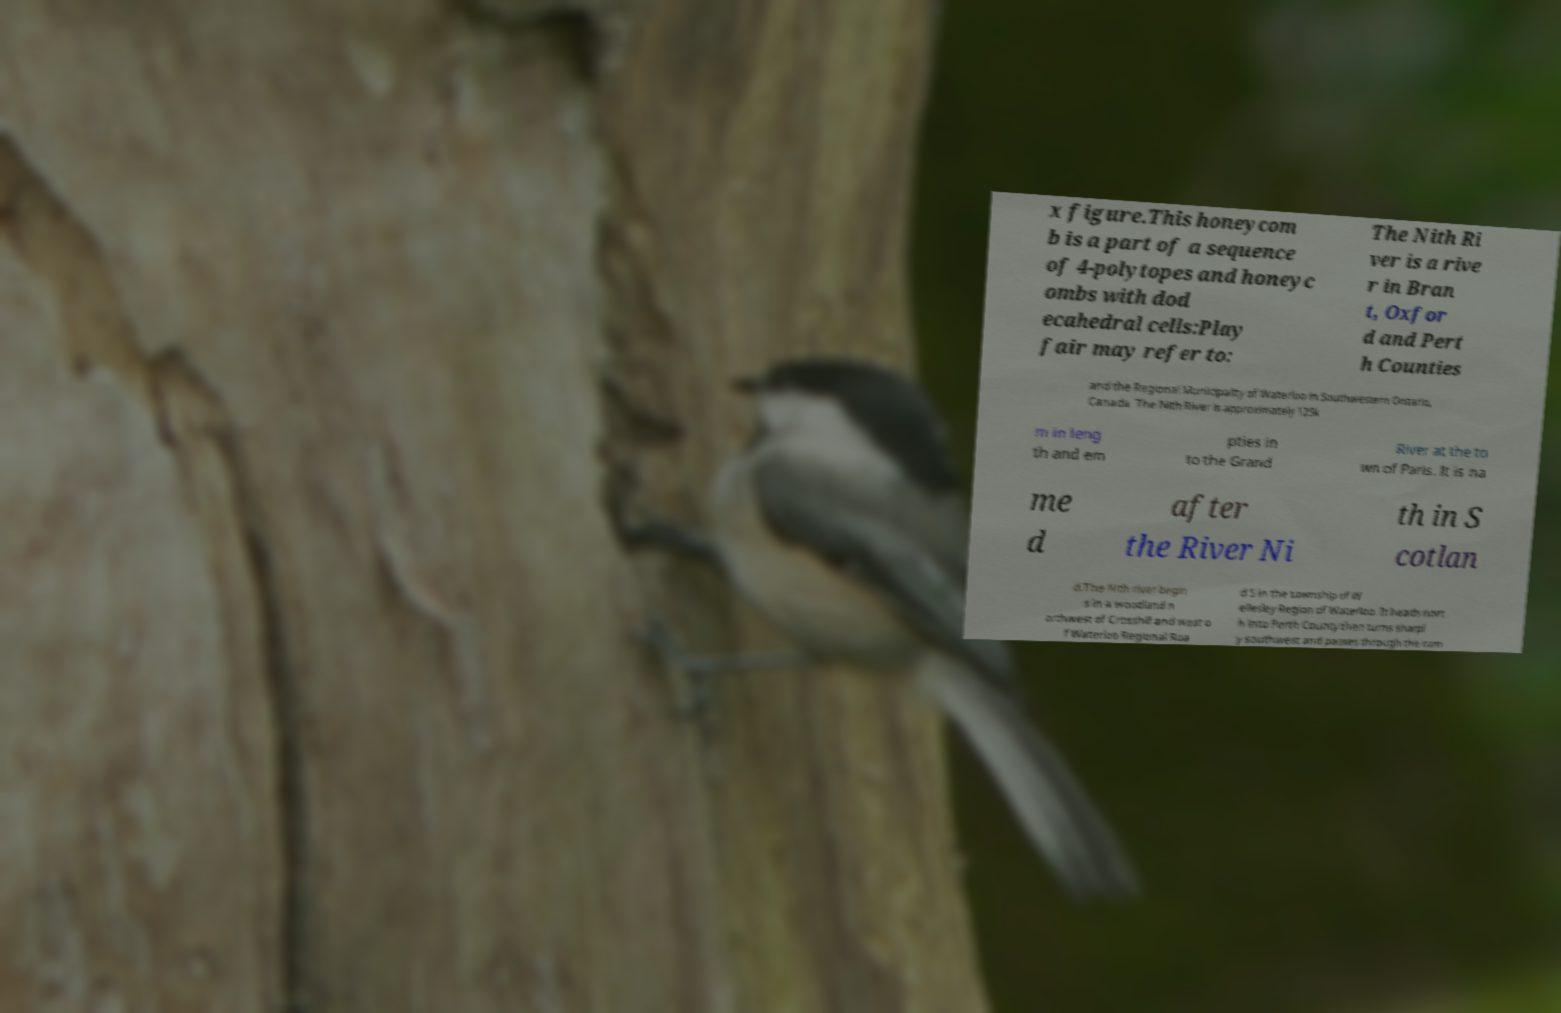Could you assist in decoding the text presented in this image and type it out clearly? x figure.This honeycom b is a part of a sequence of 4-polytopes and honeyc ombs with dod ecahedral cells:Play fair may refer to: The Nith Ri ver is a rive r in Bran t, Oxfor d and Pert h Counties and the Regional Municipality of Waterloo in Southwestern Ontario, Canada. The Nith River is approximately 125k m in leng th and em pties in to the Grand River at the to wn of Paris. It is na me d after the River Ni th in S cotlan d.The Nith river begin s in a woodland n orthwest of Crosshill and west o f Waterloo Regional Roa d 5 in the township of W ellesley Region of Waterloo. It heads nort h into Perth County then turns sharpl y southwest and passes through the com 